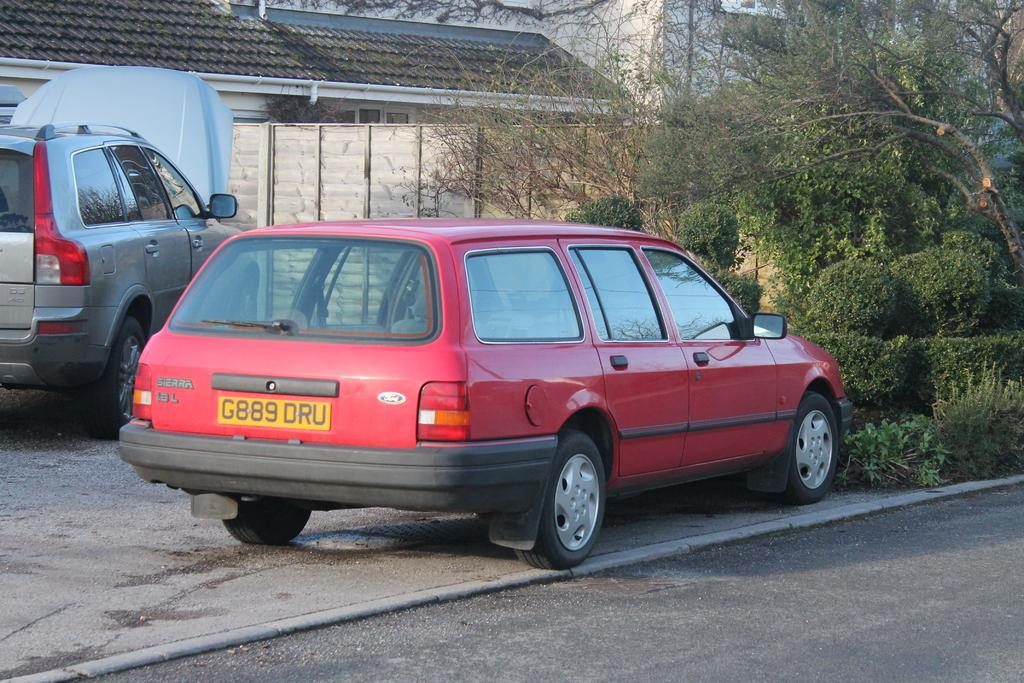How many vehicles are on the ground in the image? There are two vehicles on the ground in the image. What can be seen in the background of the image? There are two houses, a pipe on the wall, trees, plants, a gate, and a wall visible in the background. What is at the bottom of the image? A road is visible at the bottom of the image. What type of steel is used to construct the volcano in the image? There is no volcano present in the image, so it is not possible to determine what type of steel might be used in its construction. 